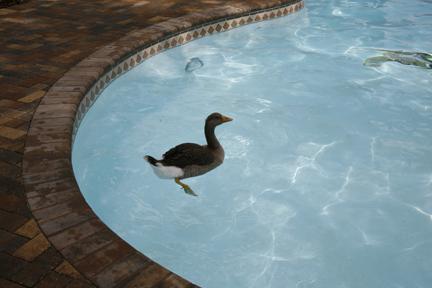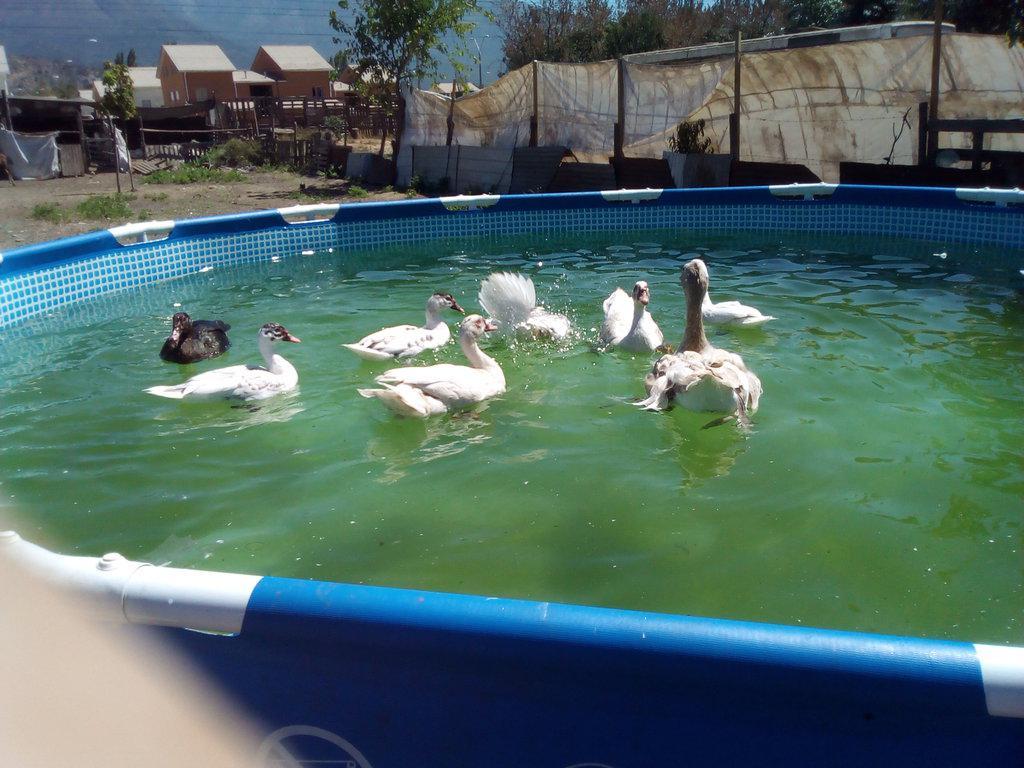The first image is the image on the left, the second image is the image on the right. Analyze the images presented: Is the assertion "Each image shows exactly one bird floating on water, and at least one of the birds is a Canadian goose." valid? Answer yes or no. No. The first image is the image on the left, the second image is the image on the right. Examine the images to the left and right. Is the description "The right image contains at least two ducks." accurate? Answer yes or no. Yes. 